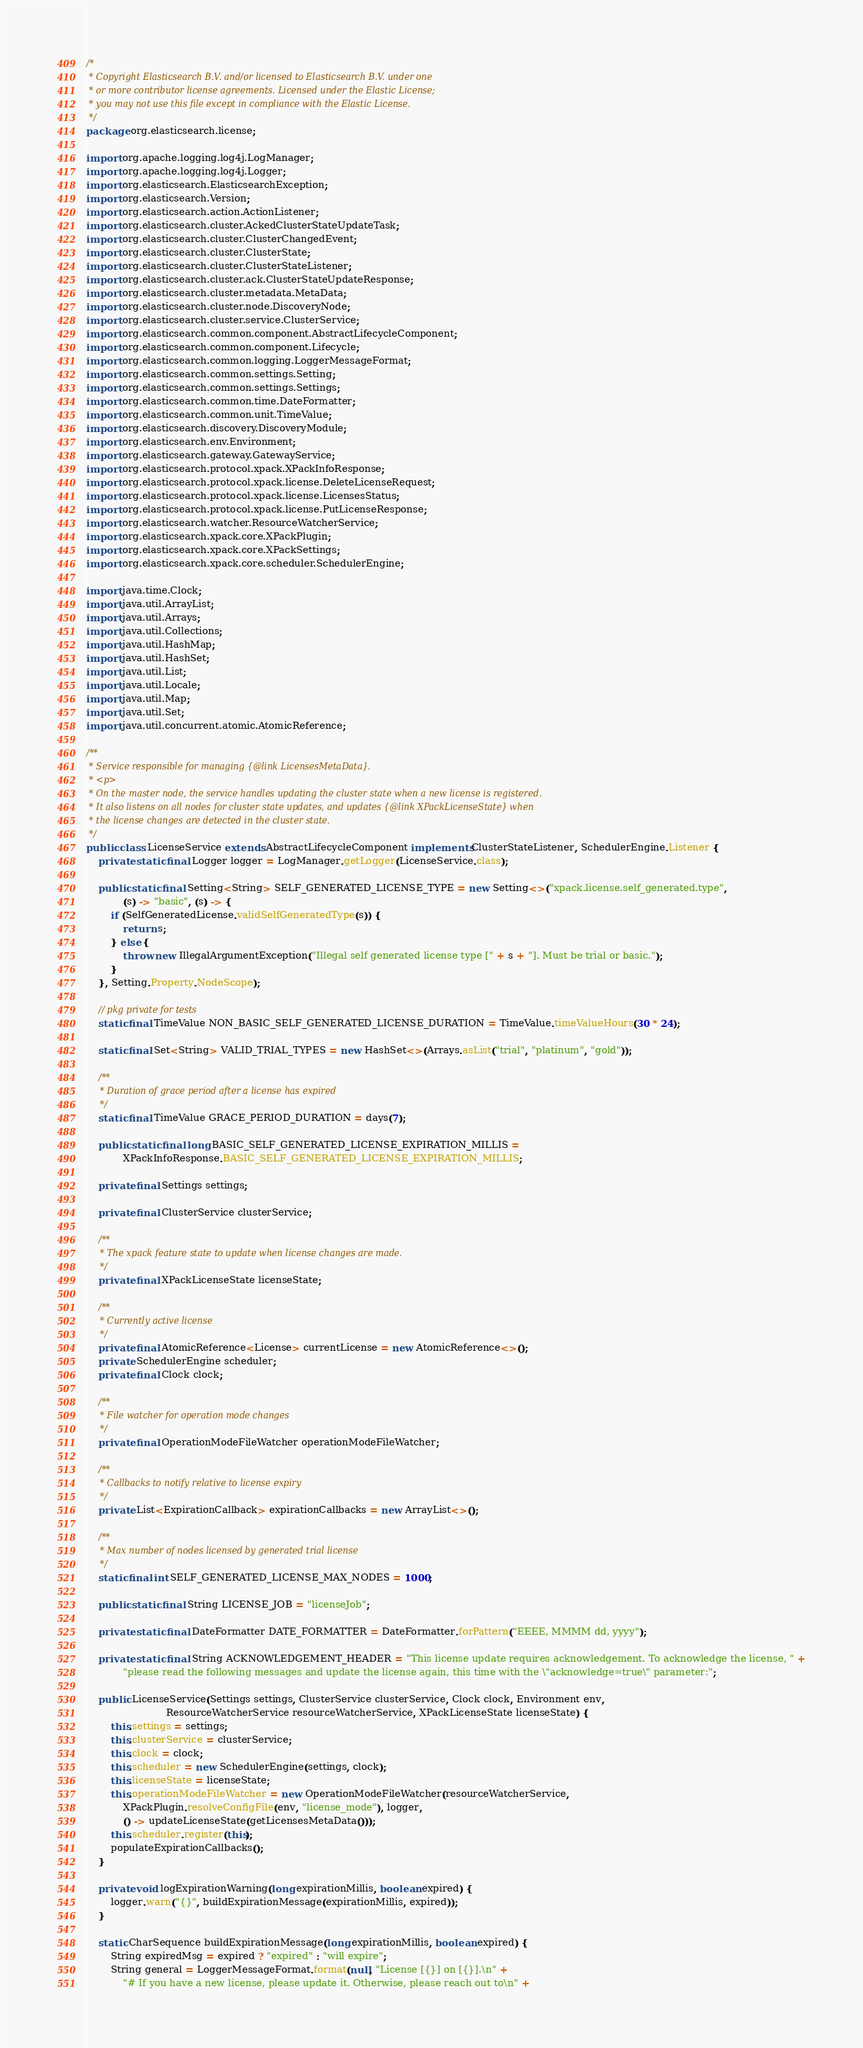Convert code to text. <code><loc_0><loc_0><loc_500><loc_500><_Java_>/*
 * Copyright Elasticsearch B.V. and/or licensed to Elasticsearch B.V. under one
 * or more contributor license agreements. Licensed under the Elastic License;
 * you may not use this file except in compliance with the Elastic License.
 */
package org.elasticsearch.license;

import org.apache.logging.log4j.LogManager;
import org.apache.logging.log4j.Logger;
import org.elasticsearch.ElasticsearchException;
import org.elasticsearch.Version;
import org.elasticsearch.action.ActionListener;
import org.elasticsearch.cluster.AckedClusterStateUpdateTask;
import org.elasticsearch.cluster.ClusterChangedEvent;
import org.elasticsearch.cluster.ClusterState;
import org.elasticsearch.cluster.ClusterStateListener;
import org.elasticsearch.cluster.ack.ClusterStateUpdateResponse;
import org.elasticsearch.cluster.metadata.MetaData;
import org.elasticsearch.cluster.node.DiscoveryNode;
import org.elasticsearch.cluster.service.ClusterService;
import org.elasticsearch.common.component.AbstractLifecycleComponent;
import org.elasticsearch.common.component.Lifecycle;
import org.elasticsearch.common.logging.LoggerMessageFormat;
import org.elasticsearch.common.settings.Setting;
import org.elasticsearch.common.settings.Settings;
import org.elasticsearch.common.time.DateFormatter;
import org.elasticsearch.common.unit.TimeValue;
import org.elasticsearch.discovery.DiscoveryModule;
import org.elasticsearch.env.Environment;
import org.elasticsearch.gateway.GatewayService;
import org.elasticsearch.protocol.xpack.XPackInfoResponse;
import org.elasticsearch.protocol.xpack.license.DeleteLicenseRequest;
import org.elasticsearch.protocol.xpack.license.LicensesStatus;
import org.elasticsearch.protocol.xpack.license.PutLicenseResponse;
import org.elasticsearch.watcher.ResourceWatcherService;
import org.elasticsearch.xpack.core.XPackPlugin;
import org.elasticsearch.xpack.core.XPackSettings;
import org.elasticsearch.xpack.core.scheduler.SchedulerEngine;

import java.time.Clock;
import java.util.ArrayList;
import java.util.Arrays;
import java.util.Collections;
import java.util.HashMap;
import java.util.HashSet;
import java.util.List;
import java.util.Locale;
import java.util.Map;
import java.util.Set;
import java.util.concurrent.atomic.AtomicReference;

/**
 * Service responsible for managing {@link LicensesMetaData}.
 * <p>
 * On the master node, the service handles updating the cluster state when a new license is registered.
 * It also listens on all nodes for cluster state updates, and updates {@link XPackLicenseState} when
 * the license changes are detected in the cluster state.
 */
public class LicenseService extends AbstractLifecycleComponent implements ClusterStateListener, SchedulerEngine.Listener {
    private static final Logger logger = LogManager.getLogger(LicenseService.class);

    public static final Setting<String> SELF_GENERATED_LICENSE_TYPE = new Setting<>("xpack.license.self_generated.type",
            (s) -> "basic", (s) -> {
        if (SelfGeneratedLicense.validSelfGeneratedType(s)) {
            return s;
        } else {
            throw new IllegalArgumentException("Illegal self generated license type [" + s + "]. Must be trial or basic.");
        }
    }, Setting.Property.NodeScope);

    // pkg private for tests
    static final TimeValue NON_BASIC_SELF_GENERATED_LICENSE_DURATION = TimeValue.timeValueHours(30 * 24);

    static final Set<String> VALID_TRIAL_TYPES = new HashSet<>(Arrays.asList("trial", "platinum", "gold"));

    /**
     * Duration of grace period after a license has expired
     */
    static final TimeValue GRACE_PERIOD_DURATION = days(7);

    public static final long BASIC_SELF_GENERATED_LICENSE_EXPIRATION_MILLIS =
            XPackInfoResponse.BASIC_SELF_GENERATED_LICENSE_EXPIRATION_MILLIS;

    private final Settings settings;

    private final ClusterService clusterService;

    /**
     * The xpack feature state to update when license changes are made.
     */
    private final XPackLicenseState licenseState;

    /**
     * Currently active license
     */
    private final AtomicReference<License> currentLicense = new AtomicReference<>();
    private SchedulerEngine scheduler;
    private final Clock clock;

    /**
     * File watcher for operation mode changes
     */
    private final OperationModeFileWatcher operationModeFileWatcher;

    /**
     * Callbacks to notify relative to license expiry
     */
    private List<ExpirationCallback> expirationCallbacks = new ArrayList<>();

    /**
     * Max number of nodes licensed by generated trial license
     */
    static final int SELF_GENERATED_LICENSE_MAX_NODES = 1000;

    public static final String LICENSE_JOB = "licenseJob";

    private static final DateFormatter DATE_FORMATTER = DateFormatter.forPattern("EEEE, MMMM dd, yyyy");

    private static final String ACKNOWLEDGEMENT_HEADER = "This license update requires acknowledgement. To acknowledge the license, " +
            "please read the following messages and update the license again, this time with the \"acknowledge=true\" parameter:";

    public LicenseService(Settings settings, ClusterService clusterService, Clock clock, Environment env,
                          ResourceWatcherService resourceWatcherService, XPackLicenseState licenseState) {
        this.settings = settings;
        this.clusterService = clusterService;
        this.clock = clock;
        this.scheduler = new SchedulerEngine(settings, clock);
        this.licenseState = licenseState;
        this.operationModeFileWatcher = new OperationModeFileWatcher(resourceWatcherService,
            XPackPlugin.resolveConfigFile(env, "license_mode"), logger,
            () -> updateLicenseState(getLicensesMetaData()));
        this.scheduler.register(this);
        populateExpirationCallbacks();
    }

    private void logExpirationWarning(long expirationMillis, boolean expired) {
        logger.warn("{}", buildExpirationMessage(expirationMillis, expired));
    }

    static CharSequence buildExpirationMessage(long expirationMillis, boolean expired) {
        String expiredMsg = expired ? "expired" : "will expire";
        String general = LoggerMessageFormat.format(null, "License [{}] on [{}].\n" +
            "# If you have a new license, please update it. Otherwise, please reach out to\n" +</code> 